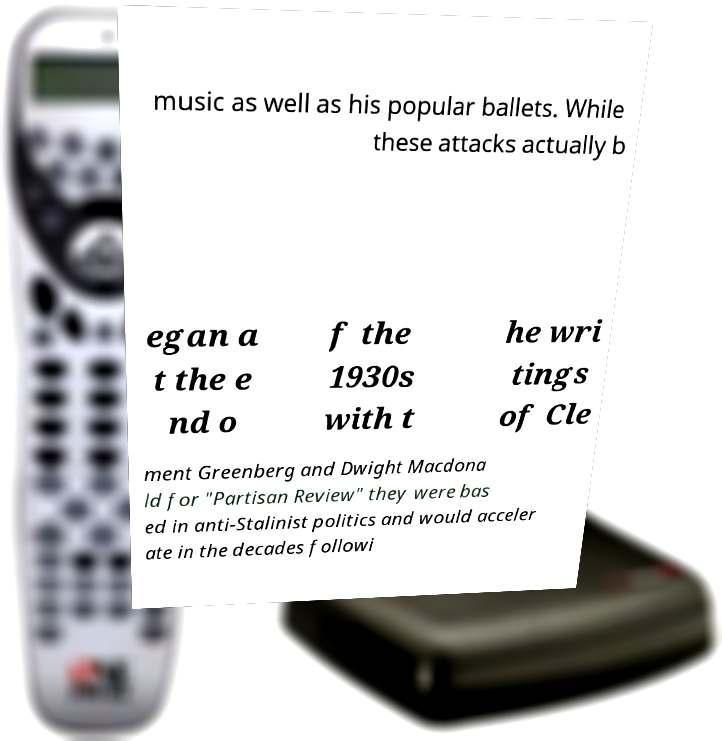Can you read and provide the text displayed in the image?This photo seems to have some interesting text. Can you extract and type it out for me? music as well as his popular ballets. While these attacks actually b egan a t the e nd o f the 1930s with t he wri tings of Cle ment Greenberg and Dwight Macdona ld for "Partisan Review" they were bas ed in anti-Stalinist politics and would acceler ate in the decades followi 